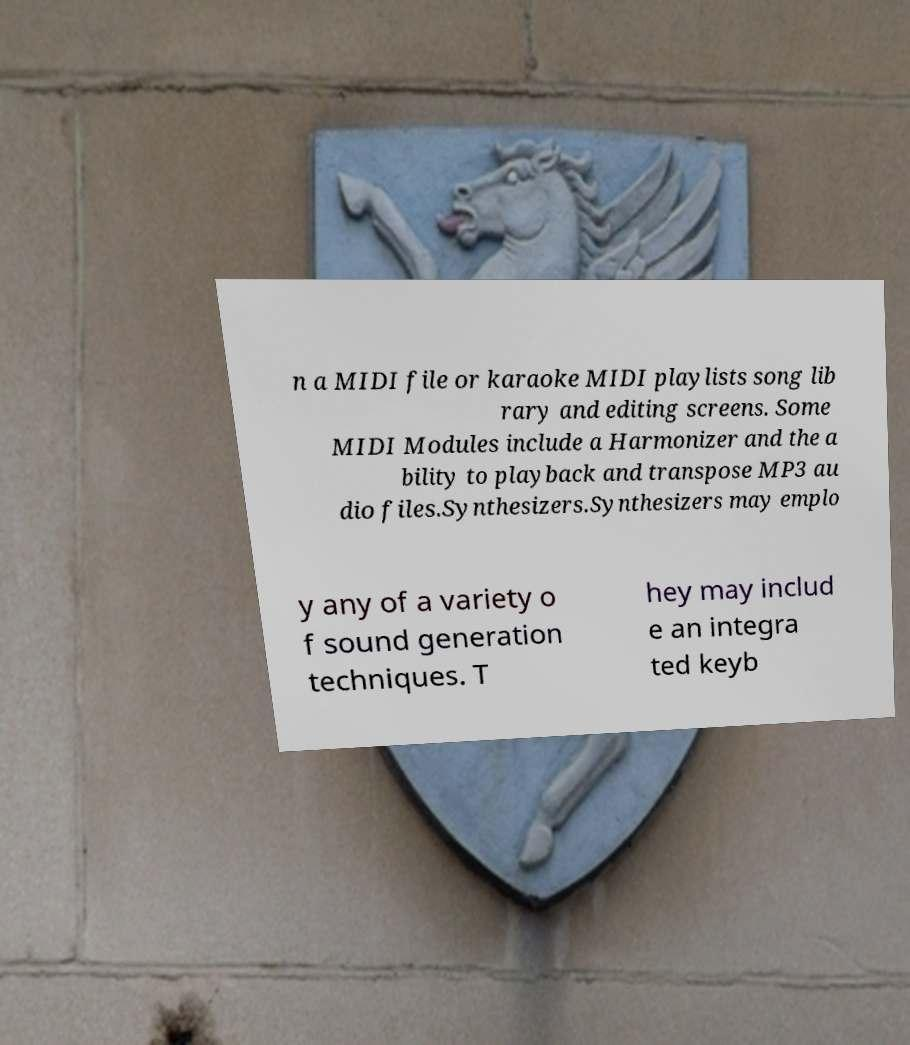Can you read and provide the text displayed in the image?This photo seems to have some interesting text. Can you extract and type it out for me? n a MIDI file or karaoke MIDI playlists song lib rary and editing screens. Some MIDI Modules include a Harmonizer and the a bility to playback and transpose MP3 au dio files.Synthesizers.Synthesizers may emplo y any of a variety o f sound generation techniques. T hey may includ e an integra ted keyb 